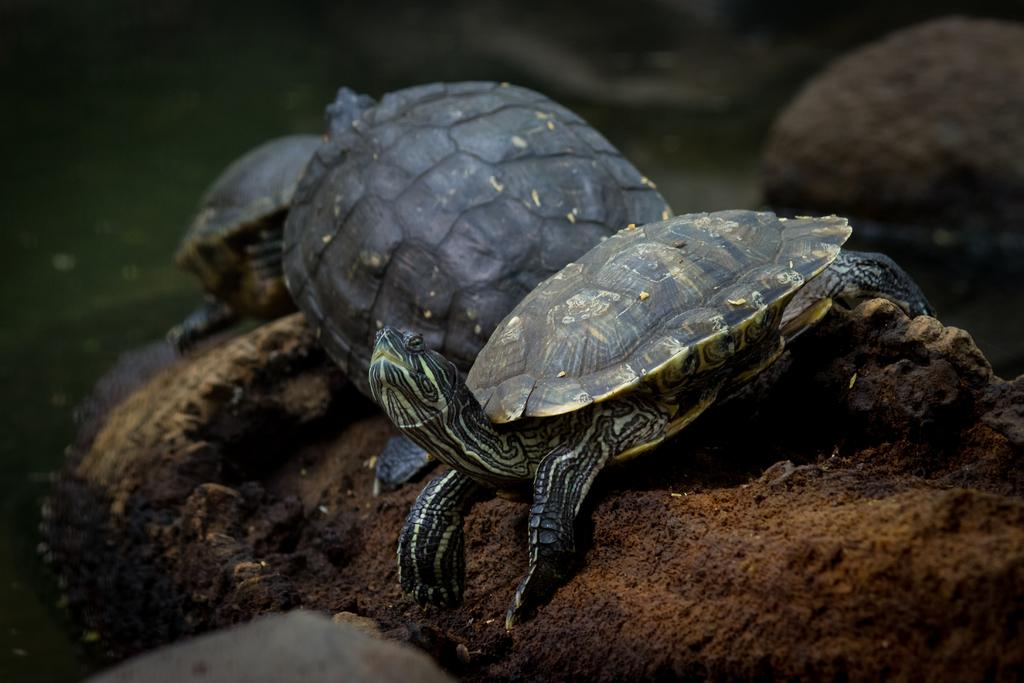What type of animals are present in the image? There are turtles in the image. What type of cap is the mailbox wearing in the image? There is no mailbox or cap present in the image; it only features turtles. 